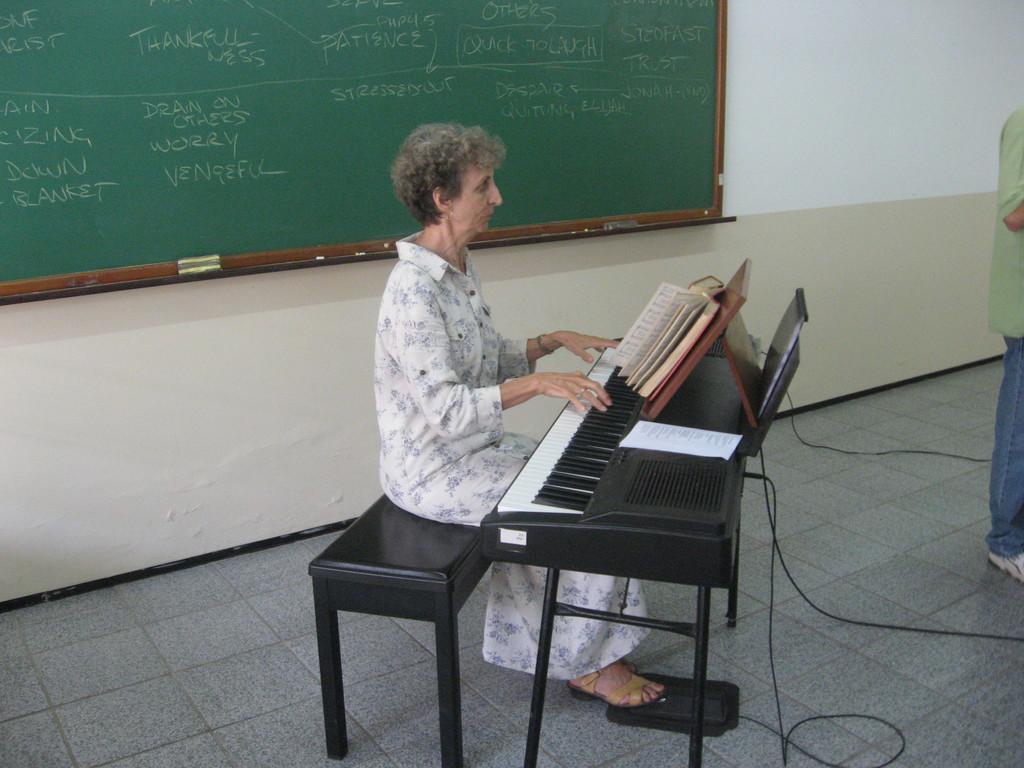In one or two sentences, can you explain what this image depicts? This picture shows a woman seated on the stool and playing piano and we see a book and front of her and we see a man standing and a board back of her 